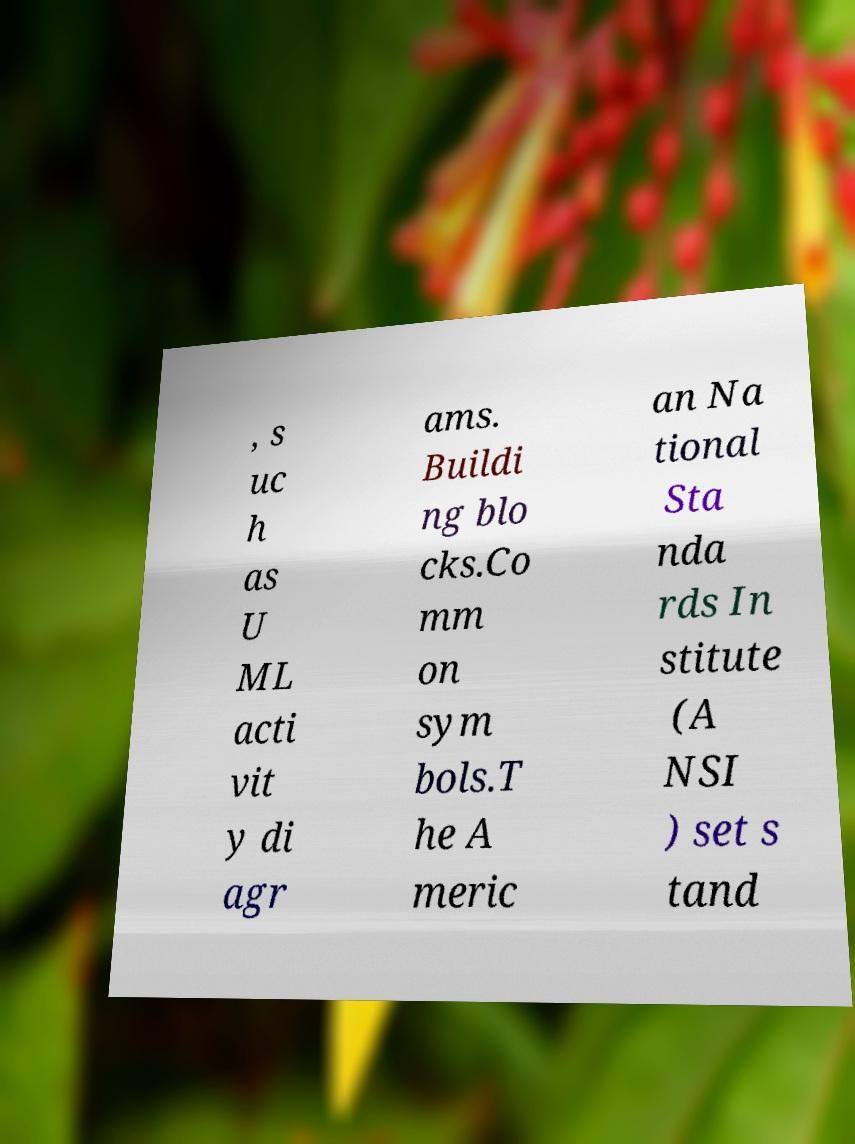Can you accurately transcribe the text from the provided image for me? , s uc h as U ML acti vit y di agr ams. Buildi ng blo cks.Co mm on sym bols.T he A meric an Na tional Sta nda rds In stitute (A NSI ) set s tand 